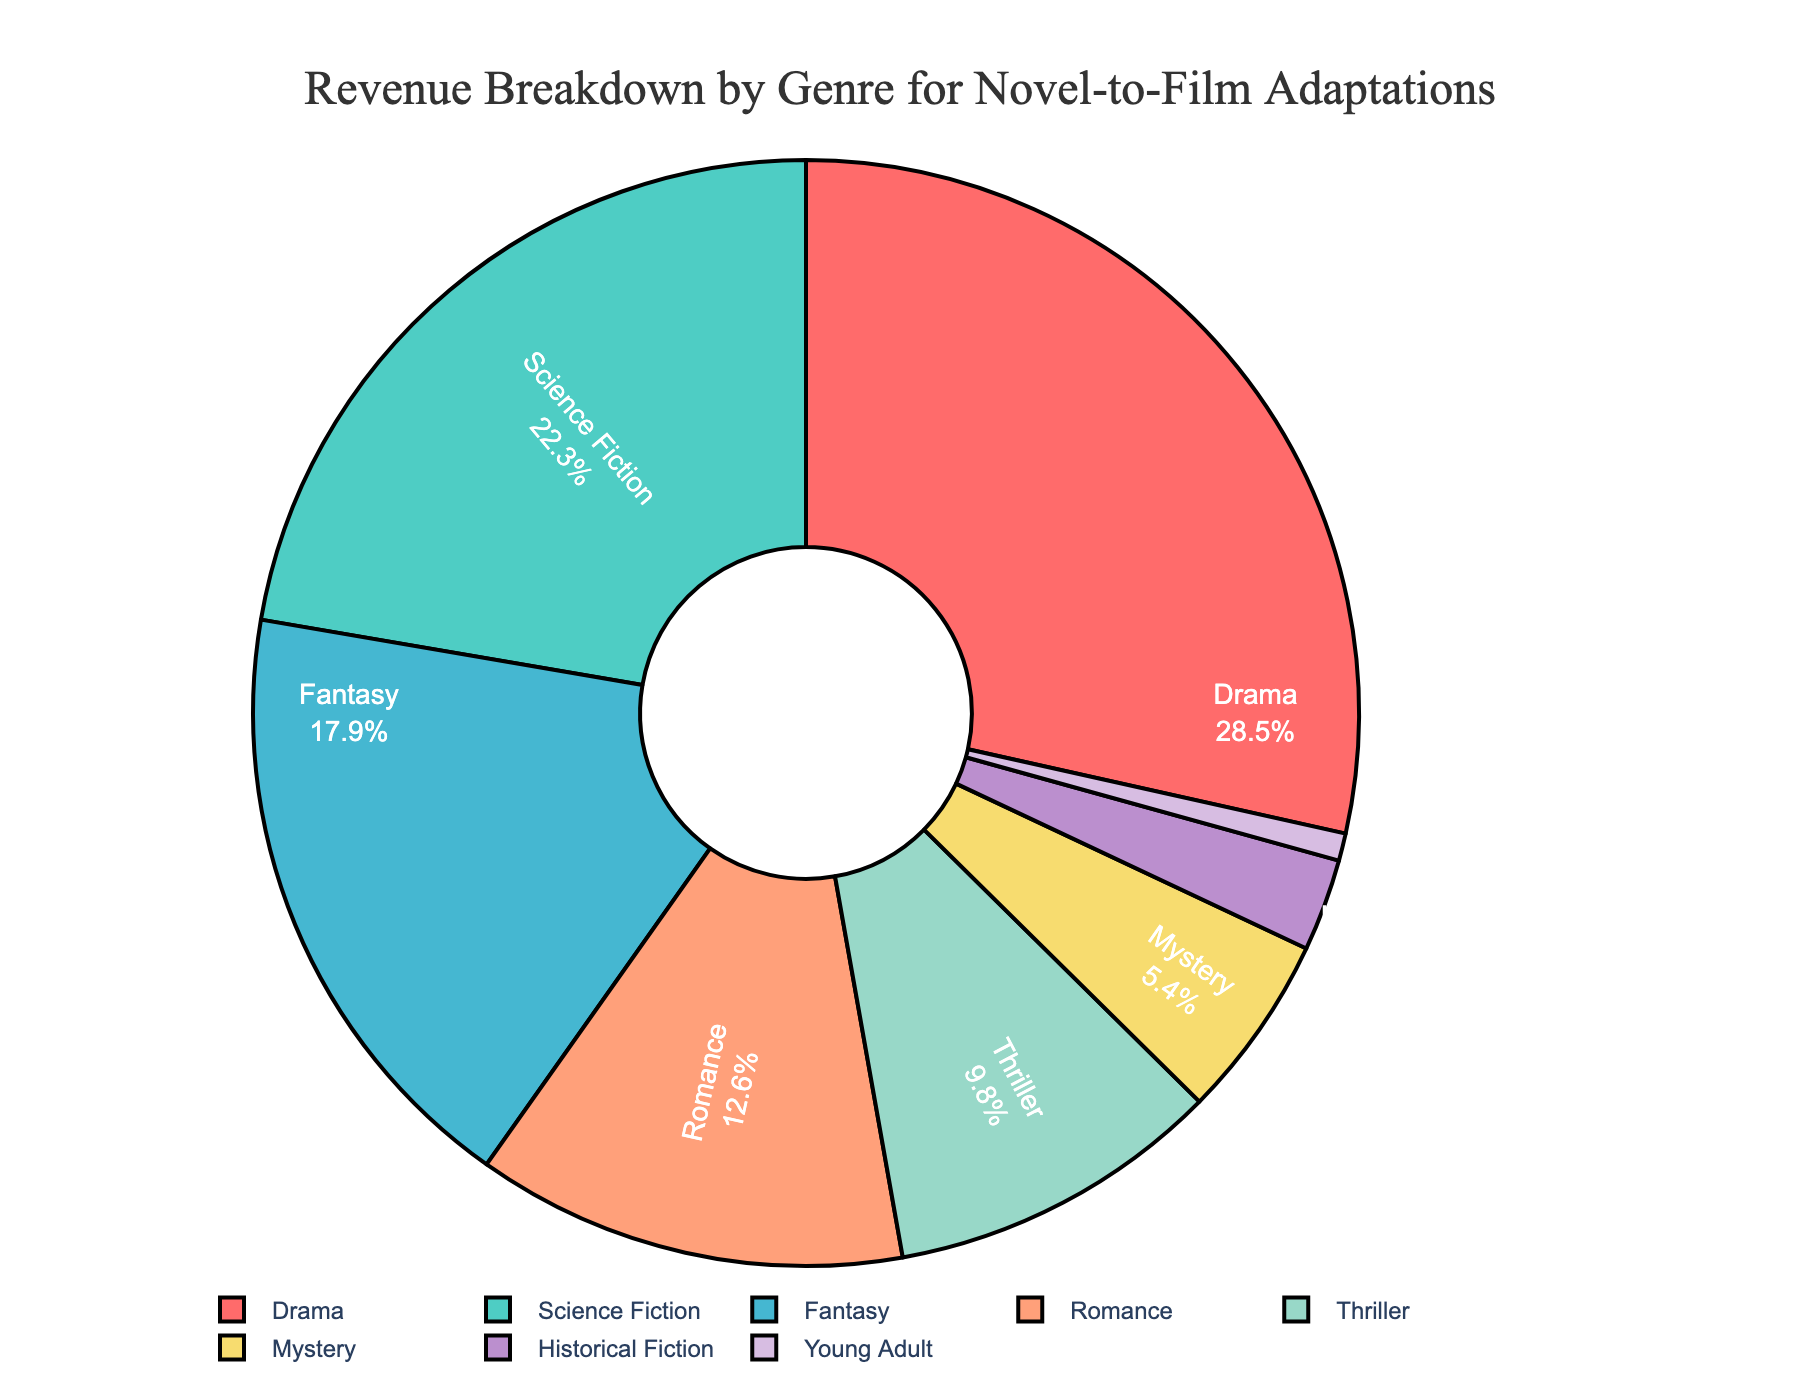What genre has the highest revenue percentage? The chart shows that Drama has the largest segment. The label for Drama displays 28.5%.
Answer: Drama Which genre contributes the least to the revenue percentage? The smallest segment in the chart is labeled "Young Adult" with a percentage of 0.8%.
Answer: Young Adult How much greater is Drama's revenue percentage compared to Romance's? Drama has 28.5% and Romance has 12.6%. The difference is 28.5 - 12.6 = 15.9%.
Answer: 15.9% What is the total revenue percentage contributed by Science Fiction and Fantasy combined? Science Fiction has 22.3% and Fantasy has 17.9%. Adding these together gives 22.3 + 17.9 = 40.2%.
Answer: 40.2% Which genre has a revenue percentage closest to 10%? The chart shows Thriller with a revenue percentage of 9.8%, which is closest to 10%.
Answer: Thriller Is the combined revenue percentage of Mystery and Historical Fiction more or less than Romance? Mystery has 5.4% and Historical Fiction has 2.7%. Their combined total is 5.4 + 2.7 = 8.1%, which is less than Romance's 12.6%.
Answer: Less Rank the top three revenue-generating genres in order. The top three revenue-generating genres, based on their percentages, are Drama (28.5%), Science Fiction (22.3%), and Fantasy (17.9%).
Answer: Drama, Science Fiction, Fantasy What is the revenue percentage for genres that make up less than 10% individually and add them together? The genres that make up less than 10% are Romance (12.6%), Thriller (9.8%), Mystery (5.4%), Historical Fiction (2.7%), and Young Adult (0.8%). Their total sum is 12.6 + 9.8 + 5.4 + 2.7 + 0.8 = 31.3%.
Answer: 31.3% How much more revenue does the Drama genre generate compared to Mystery and Historical Fiction combined? Drama generates 28.5%. Mystery and Historical Fiction together make up 5.4 + 2.7 = 8.1%. So, the difference is 28.5 - 8.1 = 20.4%.
Answer: 20.4% What color represents the Fantasy genre? The Fantasy genre segment is represented by a blue color in the chart.
Answer: Blue 